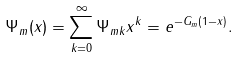<formula> <loc_0><loc_0><loc_500><loc_500>\Psi _ { m } ( x ) = \sum _ { k = 0 } ^ { \infty } \Psi _ { m k } x ^ { k } = e ^ { - G _ { m } ( 1 - x ) } .</formula> 